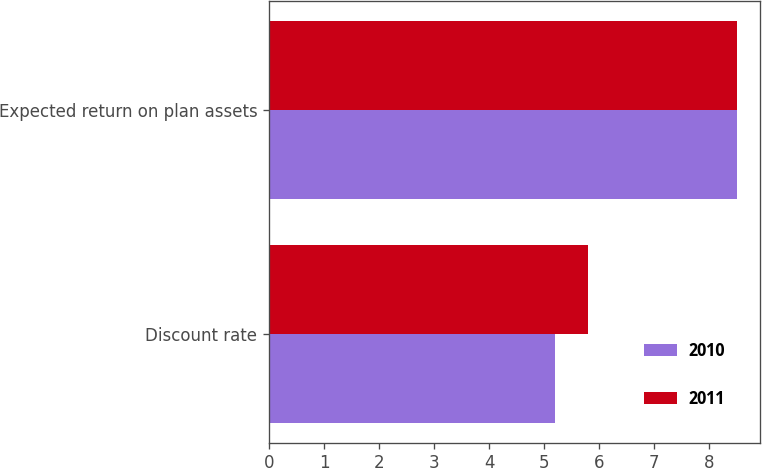Convert chart. <chart><loc_0><loc_0><loc_500><loc_500><stacked_bar_chart><ecel><fcel>Discount rate<fcel>Expected return on plan assets<nl><fcel>2010<fcel>5.2<fcel>8.5<nl><fcel>2011<fcel>5.8<fcel>8.5<nl></chart> 